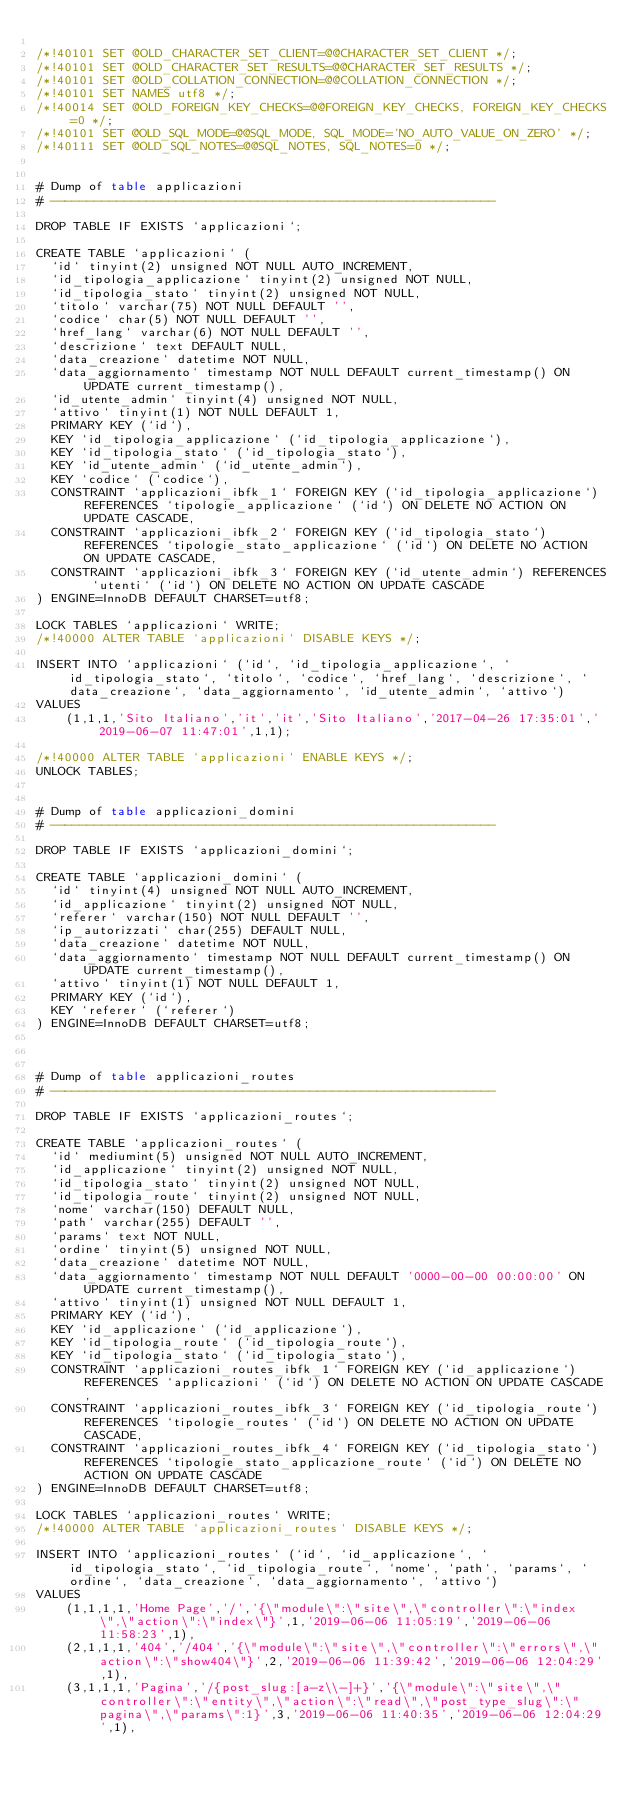<code> <loc_0><loc_0><loc_500><loc_500><_SQL_>
/*!40101 SET @OLD_CHARACTER_SET_CLIENT=@@CHARACTER_SET_CLIENT */;
/*!40101 SET @OLD_CHARACTER_SET_RESULTS=@@CHARACTER_SET_RESULTS */;
/*!40101 SET @OLD_COLLATION_CONNECTION=@@COLLATION_CONNECTION */;
/*!40101 SET NAMES utf8 */;
/*!40014 SET @OLD_FOREIGN_KEY_CHECKS=@@FOREIGN_KEY_CHECKS, FOREIGN_KEY_CHECKS=0 */;
/*!40101 SET @OLD_SQL_MODE=@@SQL_MODE, SQL_MODE='NO_AUTO_VALUE_ON_ZERO' */;
/*!40111 SET @OLD_SQL_NOTES=@@SQL_NOTES, SQL_NOTES=0 */;


# Dump of table applicazioni
# ------------------------------------------------------------

DROP TABLE IF EXISTS `applicazioni`;

CREATE TABLE `applicazioni` (
  `id` tinyint(2) unsigned NOT NULL AUTO_INCREMENT,
  `id_tipologia_applicazione` tinyint(2) unsigned NOT NULL,
  `id_tipologia_stato` tinyint(2) unsigned NOT NULL,
  `titolo` varchar(75) NOT NULL DEFAULT '',
  `codice` char(5) NOT NULL DEFAULT '',
  `href_lang` varchar(6) NOT NULL DEFAULT '',
  `descrizione` text DEFAULT NULL,
  `data_creazione` datetime NOT NULL,
  `data_aggiornamento` timestamp NOT NULL DEFAULT current_timestamp() ON UPDATE current_timestamp(),
  `id_utente_admin` tinyint(4) unsigned NOT NULL,
  `attivo` tinyint(1) NOT NULL DEFAULT 1,
  PRIMARY KEY (`id`),
  KEY `id_tipologia_applicazione` (`id_tipologia_applicazione`),
  KEY `id_tipologia_stato` (`id_tipologia_stato`),
  KEY `id_utente_admin` (`id_utente_admin`),
  KEY `codice` (`codice`),
  CONSTRAINT `applicazioni_ibfk_1` FOREIGN KEY (`id_tipologia_applicazione`) REFERENCES `tipologie_applicazione` (`id`) ON DELETE NO ACTION ON UPDATE CASCADE,
  CONSTRAINT `applicazioni_ibfk_2` FOREIGN KEY (`id_tipologia_stato`) REFERENCES `tipologie_stato_applicazione` (`id`) ON DELETE NO ACTION ON UPDATE CASCADE,
  CONSTRAINT `applicazioni_ibfk_3` FOREIGN KEY (`id_utente_admin`) REFERENCES `utenti` (`id`) ON DELETE NO ACTION ON UPDATE CASCADE
) ENGINE=InnoDB DEFAULT CHARSET=utf8;

LOCK TABLES `applicazioni` WRITE;
/*!40000 ALTER TABLE `applicazioni` DISABLE KEYS */;

INSERT INTO `applicazioni` (`id`, `id_tipologia_applicazione`, `id_tipologia_stato`, `titolo`, `codice`, `href_lang`, `descrizione`, `data_creazione`, `data_aggiornamento`, `id_utente_admin`, `attivo`)
VALUES
	(1,1,1,'Sito Italiano','it','it','Sito Italiano','2017-04-26 17:35:01','2019-06-07 11:47:01',1,1);

/*!40000 ALTER TABLE `applicazioni` ENABLE KEYS */;
UNLOCK TABLES;


# Dump of table applicazioni_domini
# ------------------------------------------------------------

DROP TABLE IF EXISTS `applicazioni_domini`;

CREATE TABLE `applicazioni_domini` (
  `id` tinyint(4) unsigned NOT NULL AUTO_INCREMENT,
  `id_applicazione` tinyint(2) unsigned NOT NULL,
  `referer` varchar(150) NOT NULL DEFAULT '',
  `ip_autorizzati` char(255) DEFAULT NULL,
  `data_creazione` datetime NOT NULL,
  `data_aggiornamento` timestamp NOT NULL DEFAULT current_timestamp() ON UPDATE current_timestamp(),
  `attivo` tinyint(1) NOT NULL DEFAULT 1,
  PRIMARY KEY (`id`),
  KEY `referer` (`referer`)
) ENGINE=InnoDB DEFAULT CHARSET=utf8;



# Dump of table applicazioni_routes
# ------------------------------------------------------------

DROP TABLE IF EXISTS `applicazioni_routes`;

CREATE TABLE `applicazioni_routes` (
  `id` mediumint(5) unsigned NOT NULL AUTO_INCREMENT,
  `id_applicazione` tinyint(2) unsigned NOT NULL,
  `id_tipologia_stato` tinyint(2) unsigned NOT NULL,
  `id_tipologia_route` tinyint(2) unsigned NOT NULL,
  `nome` varchar(150) DEFAULT NULL,
  `path` varchar(255) DEFAULT '',
  `params` text NOT NULL,
  `ordine` tinyint(5) unsigned NOT NULL,
  `data_creazione` datetime NOT NULL,
  `data_aggiornamento` timestamp NOT NULL DEFAULT '0000-00-00 00:00:00' ON UPDATE current_timestamp(),
  `attivo` tinyint(1) unsigned NOT NULL DEFAULT 1,
  PRIMARY KEY (`id`),
  KEY `id_applicazione` (`id_applicazione`),
  KEY `id_tipologia_route` (`id_tipologia_route`),
  KEY `id_tipologia_stato` (`id_tipologia_stato`),
  CONSTRAINT `applicazioni_routes_ibfk_1` FOREIGN KEY (`id_applicazione`) REFERENCES `applicazioni` (`id`) ON DELETE NO ACTION ON UPDATE CASCADE,
  CONSTRAINT `applicazioni_routes_ibfk_3` FOREIGN KEY (`id_tipologia_route`) REFERENCES `tipologie_routes` (`id`) ON DELETE NO ACTION ON UPDATE CASCADE,
  CONSTRAINT `applicazioni_routes_ibfk_4` FOREIGN KEY (`id_tipologia_stato`) REFERENCES `tipologie_stato_applicazione_route` (`id`) ON DELETE NO ACTION ON UPDATE CASCADE
) ENGINE=InnoDB DEFAULT CHARSET=utf8;

LOCK TABLES `applicazioni_routes` WRITE;
/*!40000 ALTER TABLE `applicazioni_routes` DISABLE KEYS */;

INSERT INTO `applicazioni_routes` (`id`, `id_applicazione`, `id_tipologia_stato`, `id_tipologia_route`, `nome`, `path`, `params`, `ordine`, `data_creazione`, `data_aggiornamento`, `attivo`)
VALUES
	(1,1,1,1,'Home Page','/','{\"module\":\"site\",\"controller\":\"index\",\"action\":\"index\"}',1,'2019-06-06 11:05:19','2019-06-06 11:58:23',1),
	(2,1,1,1,'404','/404','{\"module\":\"site\",\"controller\":\"errors\",\"action\":\"show404\"}',2,'2019-06-06 11:39:42','2019-06-06 12:04:29',1),
	(3,1,1,1,'Pagina','/{post_slug:[a-z\\-]+}','{\"module\":\"site\",\"controller\":\"entity\",\"action\":\"read\",\"post_type_slug\":\"pagina\",\"params\":1}',3,'2019-06-06 11:40:35','2019-06-06 12:04:29',1),</code> 